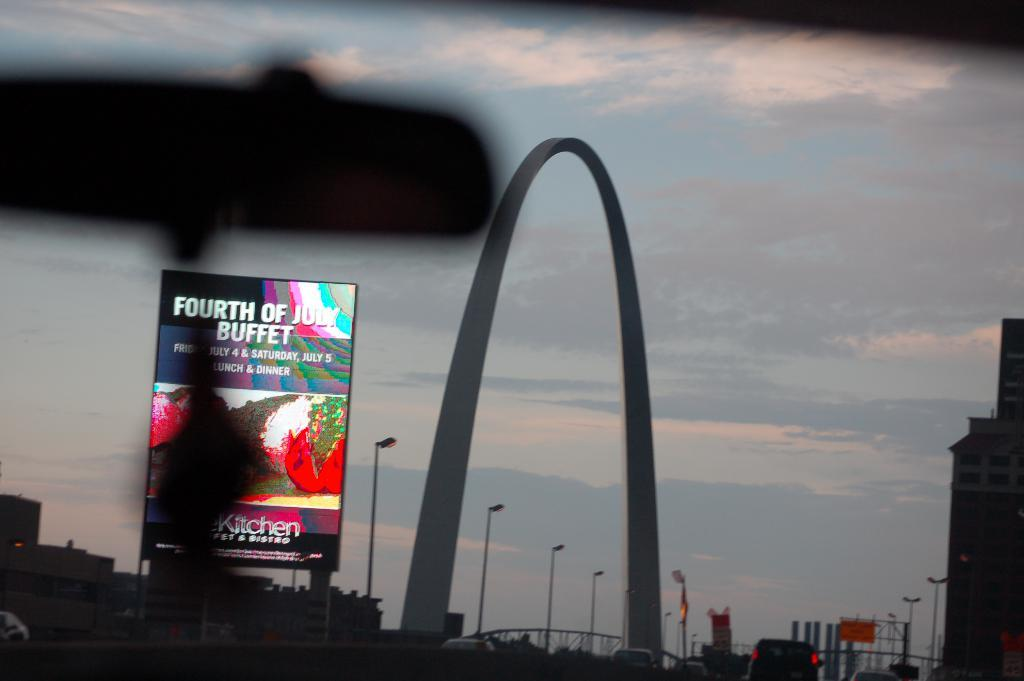<image>
Summarize the visual content of the image. a sign for the Fourth Of July buffet is near an archway 